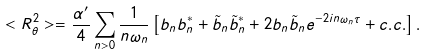Convert formula to latex. <formula><loc_0><loc_0><loc_500><loc_500>< R ^ { 2 } _ { \theta } > = \frac { \alpha ^ { \prime } } { 4 } \sum _ { n > 0 } \frac { 1 } { n \omega _ { n } } \left [ b _ { n } b _ { n } ^ { * } + \tilde { b } _ { n } \tilde { b } _ { n } ^ { * } + 2 b _ { n } \tilde { b } _ { n } e ^ { - 2 i n \omega _ { n } \tau } + c . c . \right ] .</formula> 